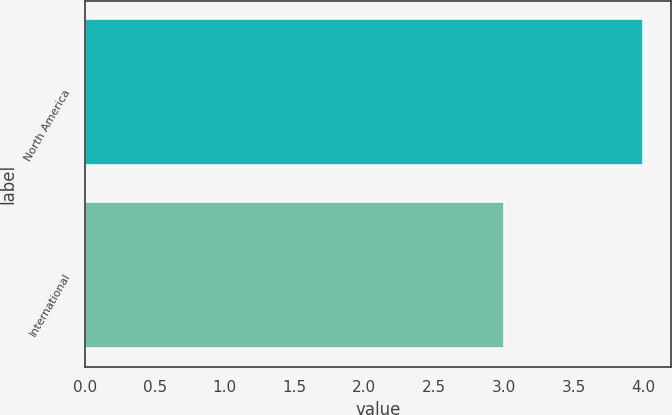Convert chart. <chart><loc_0><loc_0><loc_500><loc_500><bar_chart><fcel>North America<fcel>International<nl><fcel>4<fcel>3<nl></chart> 